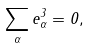Convert formula to latex. <formula><loc_0><loc_0><loc_500><loc_500>\sum _ { \alpha } e _ { \alpha } ^ { 3 } = 0 ,</formula> 